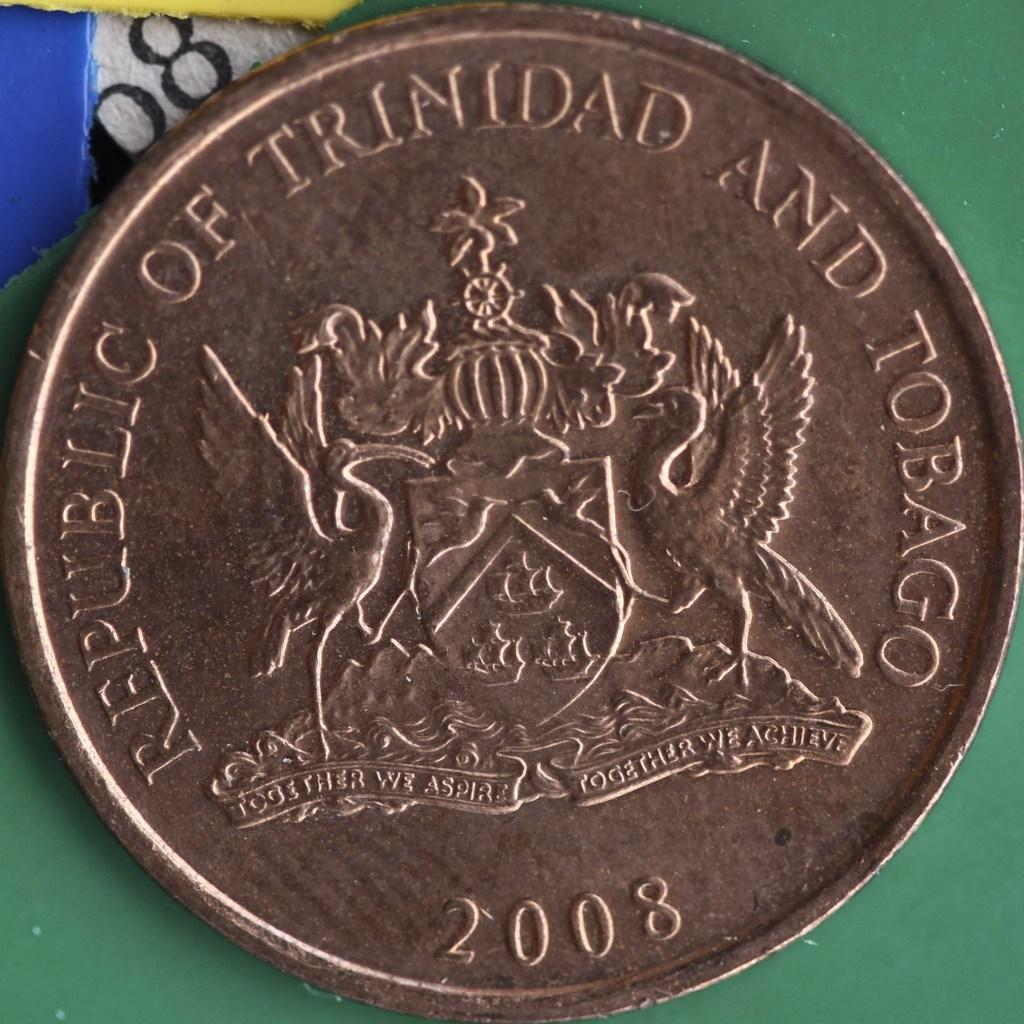Provide a one-sentence caption for the provided image. A 2008 coin from the Republic of Trinidad and Tobago. 